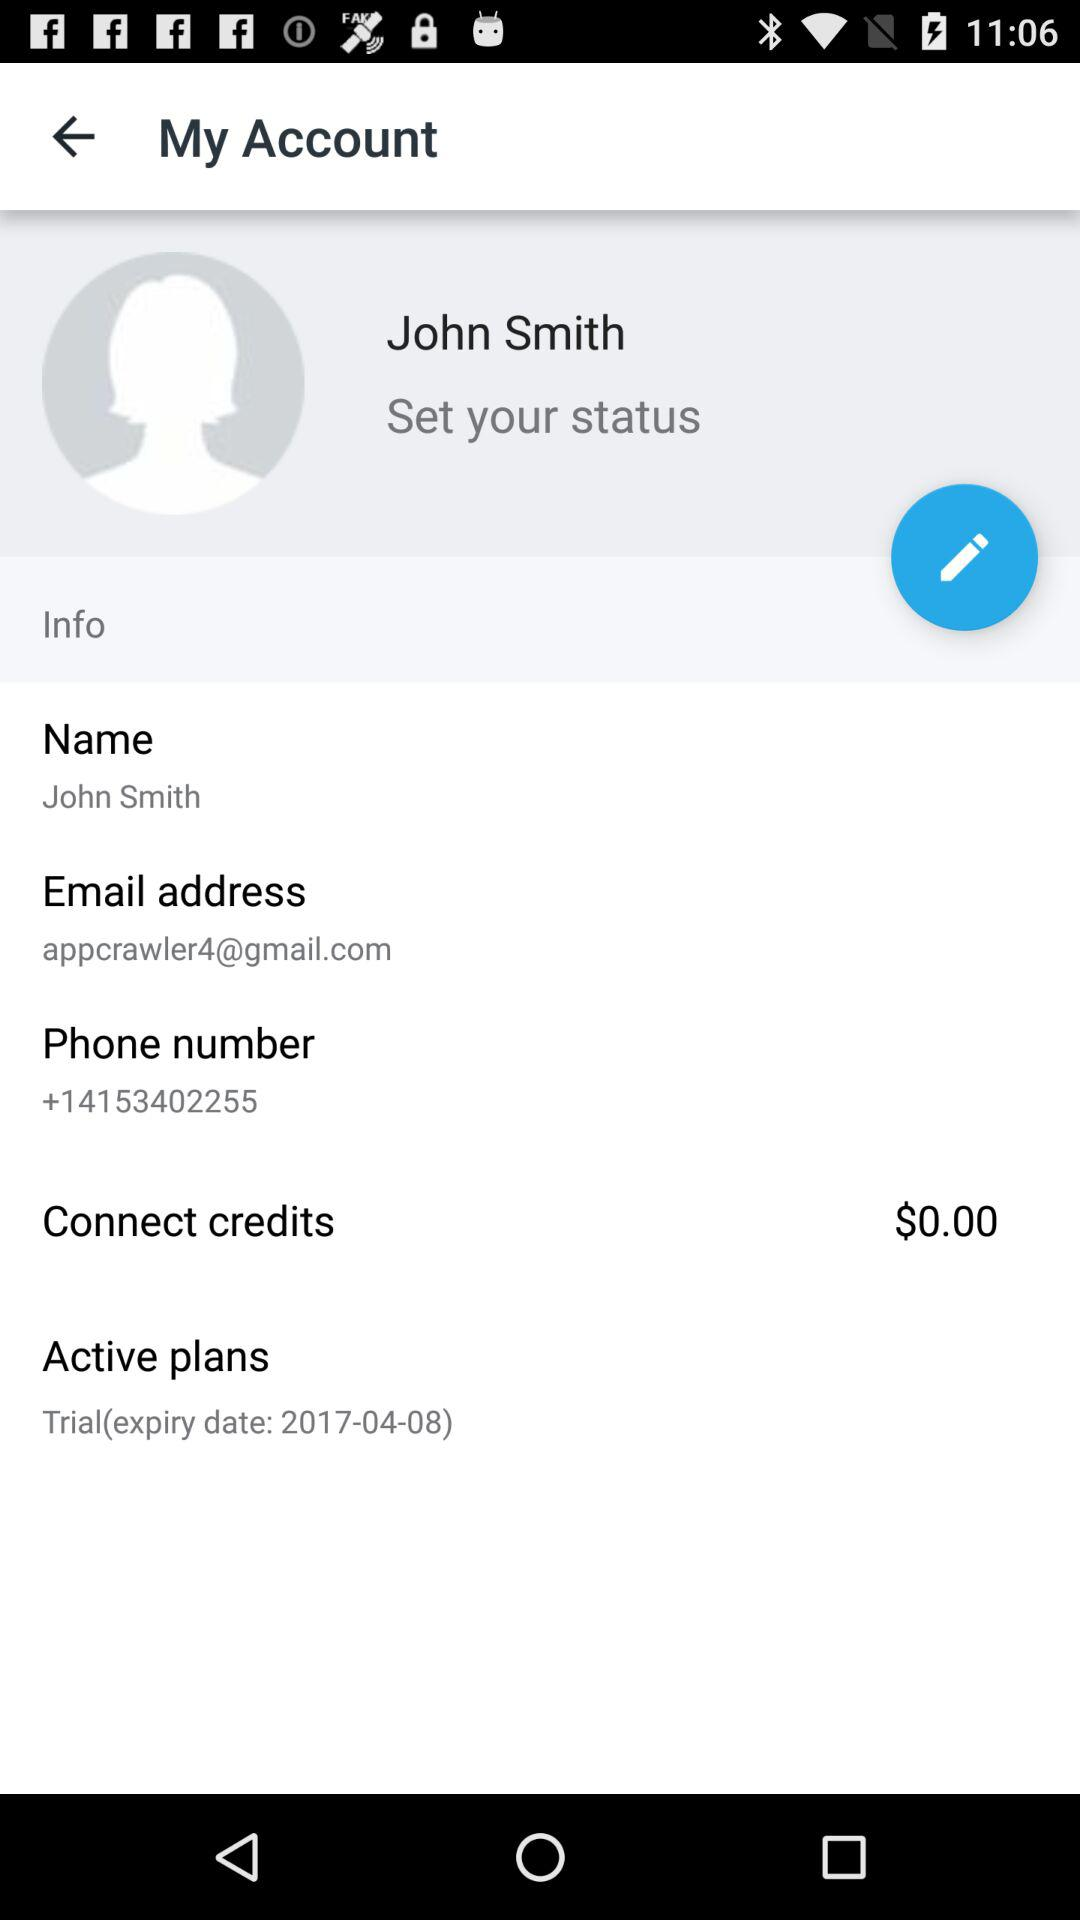What is the active plan? The active plan is "Trial". 